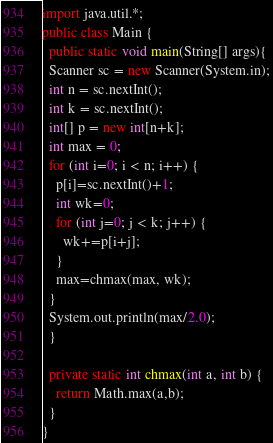<code> <loc_0><loc_0><loc_500><loc_500><_Java_>import java.util.*;
public class Main {
  public static void main(String[] args){
  Scanner sc = new Scanner(System.in);
  int n = sc.nextInt();
  int k = sc.nextInt();
  int[] p = new int[n+k];
  int max = 0;
  for (int i=0; i < n; i++) {
    p[i]=sc.nextInt()+1;
    int wk=0;
    for (int j=0; j < k; j++) {
      wk+=p[i+j];
    }
    max=chmax(max, wk);
  }
  System.out.println(max/2.0);
  }

  private static int chmax(int a, int b) {
    return Math.max(a,b);
  }
}






</code> 